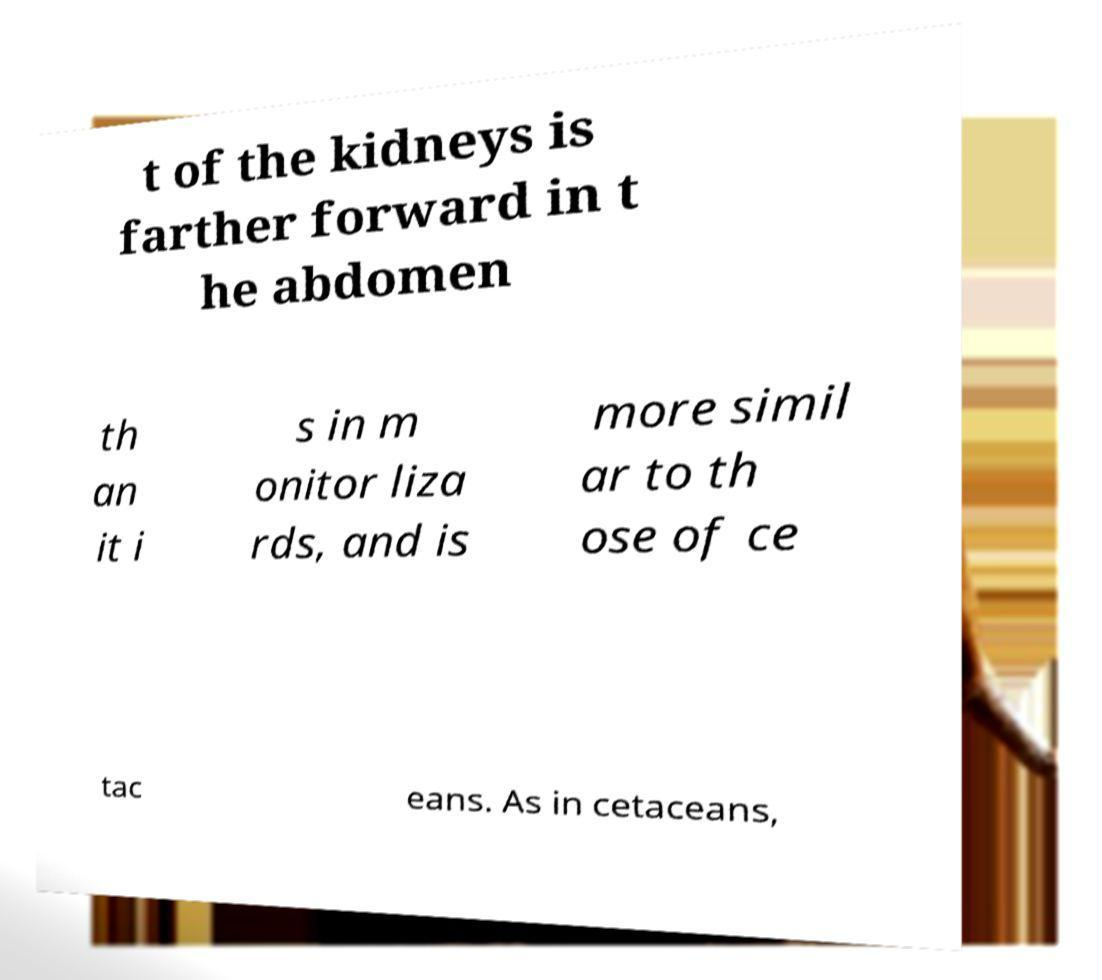For documentation purposes, I need the text within this image transcribed. Could you provide that? t of the kidneys is farther forward in t he abdomen th an it i s in m onitor liza rds, and is more simil ar to th ose of ce tac eans. As in cetaceans, 